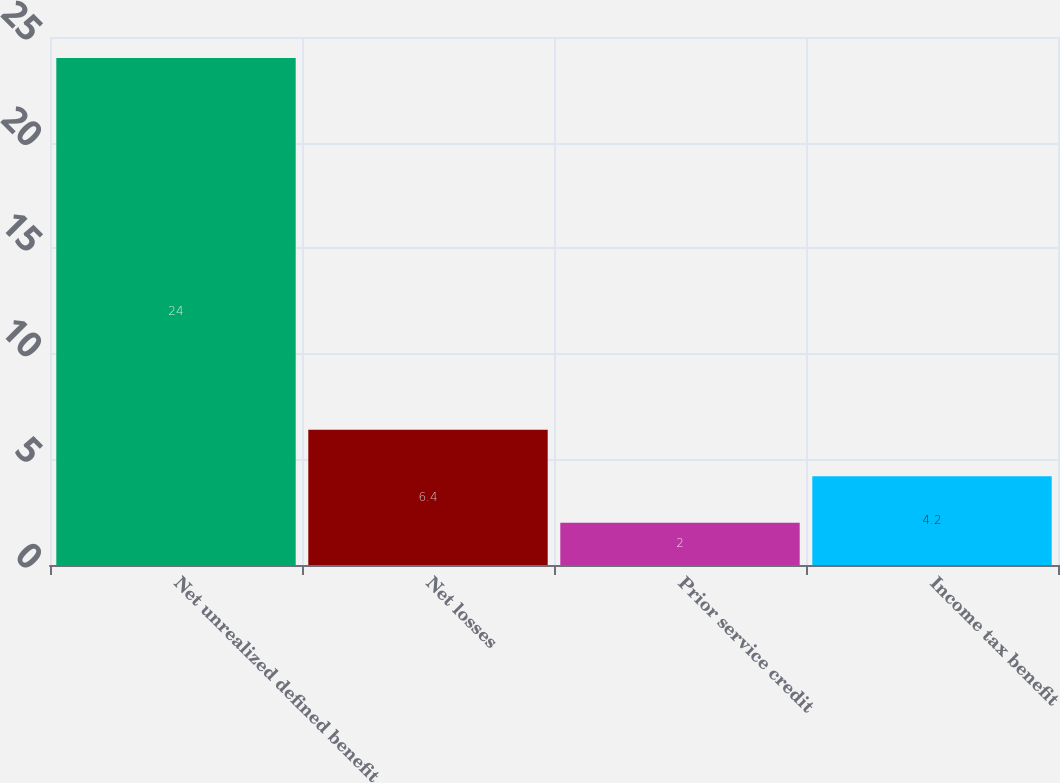Convert chart to OTSL. <chart><loc_0><loc_0><loc_500><loc_500><bar_chart><fcel>Net unrealized defined benefit<fcel>Net losses<fcel>Prior service credit<fcel>Income tax benefit<nl><fcel>24<fcel>6.4<fcel>2<fcel>4.2<nl></chart> 